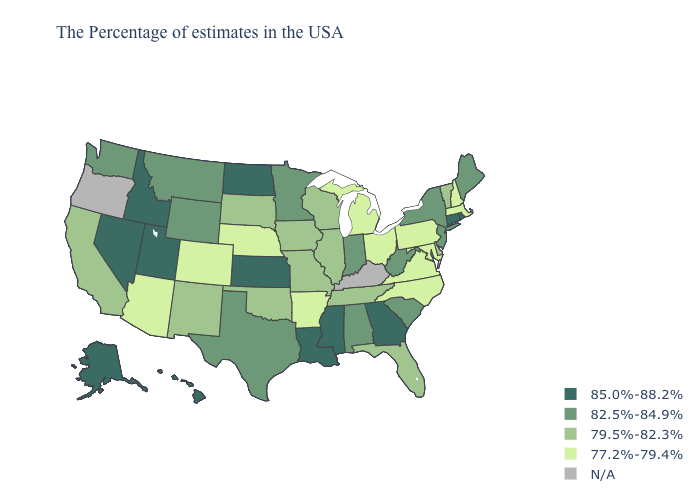Which states hav the highest value in the South?
Be succinct. Georgia, Mississippi, Louisiana. What is the value of Connecticut?
Keep it brief. 85.0%-88.2%. Does Texas have the lowest value in the USA?
Be succinct. No. Name the states that have a value in the range 79.5%-82.3%?
Give a very brief answer. Vermont, Delaware, Florida, Tennessee, Wisconsin, Illinois, Missouri, Iowa, Oklahoma, South Dakota, New Mexico, California. Name the states that have a value in the range 77.2%-79.4%?
Short answer required. Massachusetts, New Hampshire, Maryland, Pennsylvania, Virginia, North Carolina, Ohio, Michigan, Arkansas, Nebraska, Colorado, Arizona. Is the legend a continuous bar?
Answer briefly. No. What is the highest value in the West ?
Answer briefly. 85.0%-88.2%. Does the first symbol in the legend represent the smallest category?
Concise answer only. No. Which states hav the highest value in the West?
Answer briefly. Utah, Idaho, Nevada, Alaska, Hawaii. Does the first symbol in the legend represent the smallest category?
Concise answer only. No. Name the states that have a value in the range 79.5%-82.3%?
Give a very brief answer. Vermont, Delaware, Florida, Tennessee, Wisconsin, Illinois, Missouri, Iowa, Oklahoma, South Dakota, New Mexico, California. Does New Hampshire have the lowest value in the USA?
Concise answer only. Yes. What is the value of Utah?
Be succinct. 85.0%-88.2%. 